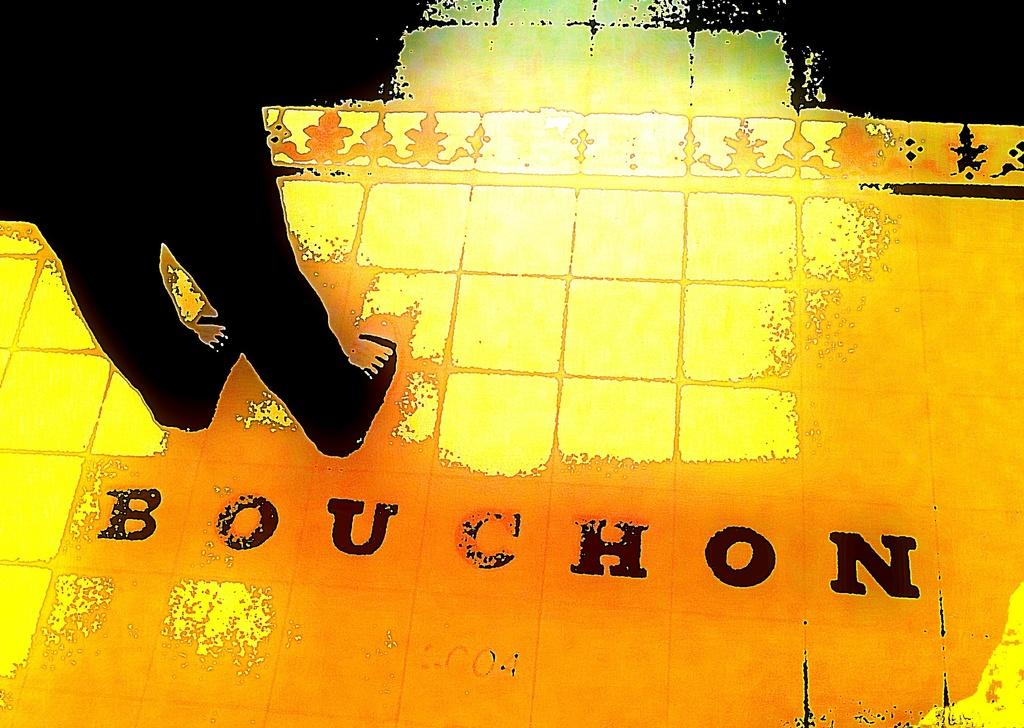What part of a person can be seen on the left side of the image? There are legs of a person on the left side of the image. What is the surface that the legs are standing on? There is a floor at the bottom of the image. What can be read or seen in the form of words in the image? There is text visible in the image. Where is the hydrant located in the image? There is no hydrant present in the image. What type of shelf can be seen on the right side of the image? There is no shelf visible in the image. 